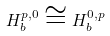<formula> <loc_0><loc_0><loc_500><loc_500>H _ { b } ^ { p , 0 } \cong H _ { b } ^ { 0 , p }</formula> 